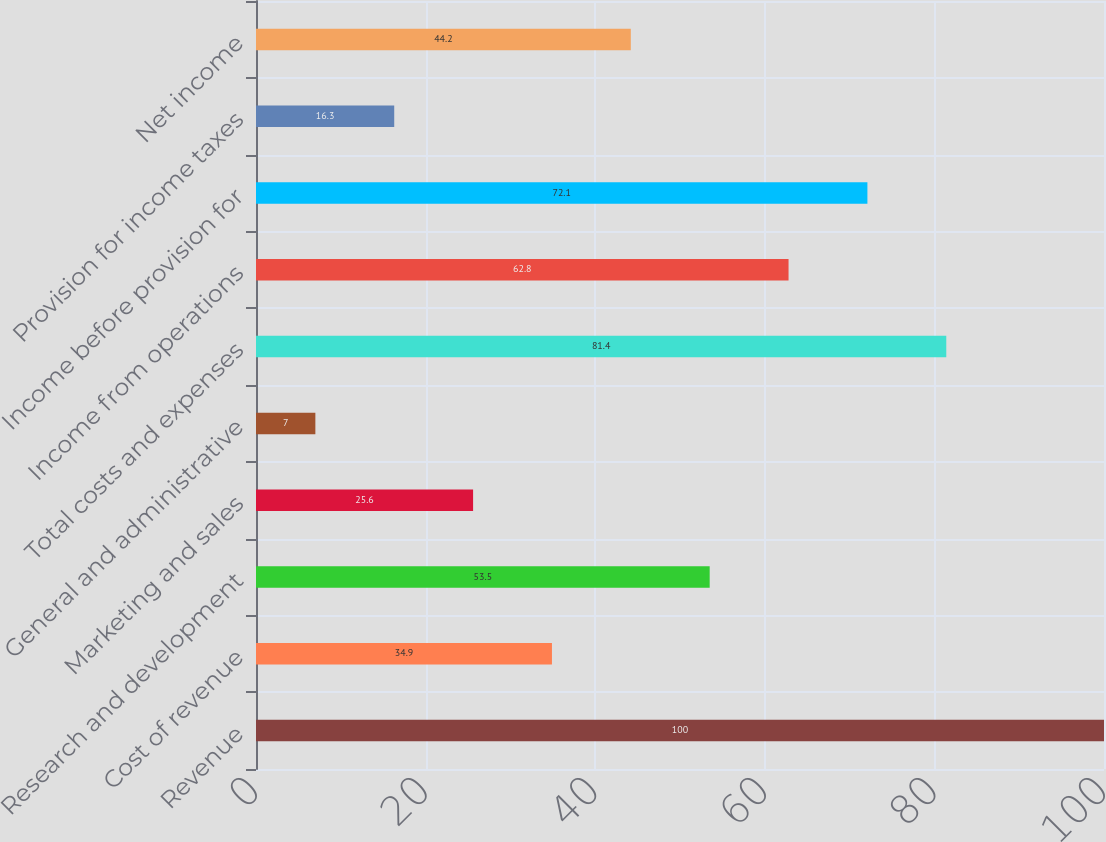Convert chart to OTSL. <chart><loc_0><loc_0><loc_500><loc_500><bar_chart><fcel>Revenue<fcel>Cost of revenue<fcel>Research and development<fcel>Marketing and sales<fcel>General and administrative<fcel>Total costs and expenses<fcel>Income from operations<fcel>Income before provision for<fcel>Provision for income taxes<fcel>Net income<nl><fcel>100<fcel>34.9<fcel>53.5<fcel>25.6<fcel>7<fcel>81.4<fcel>62.8<fcel>72.1<fcel>16.3<fcel>44.2<nl></chart> 